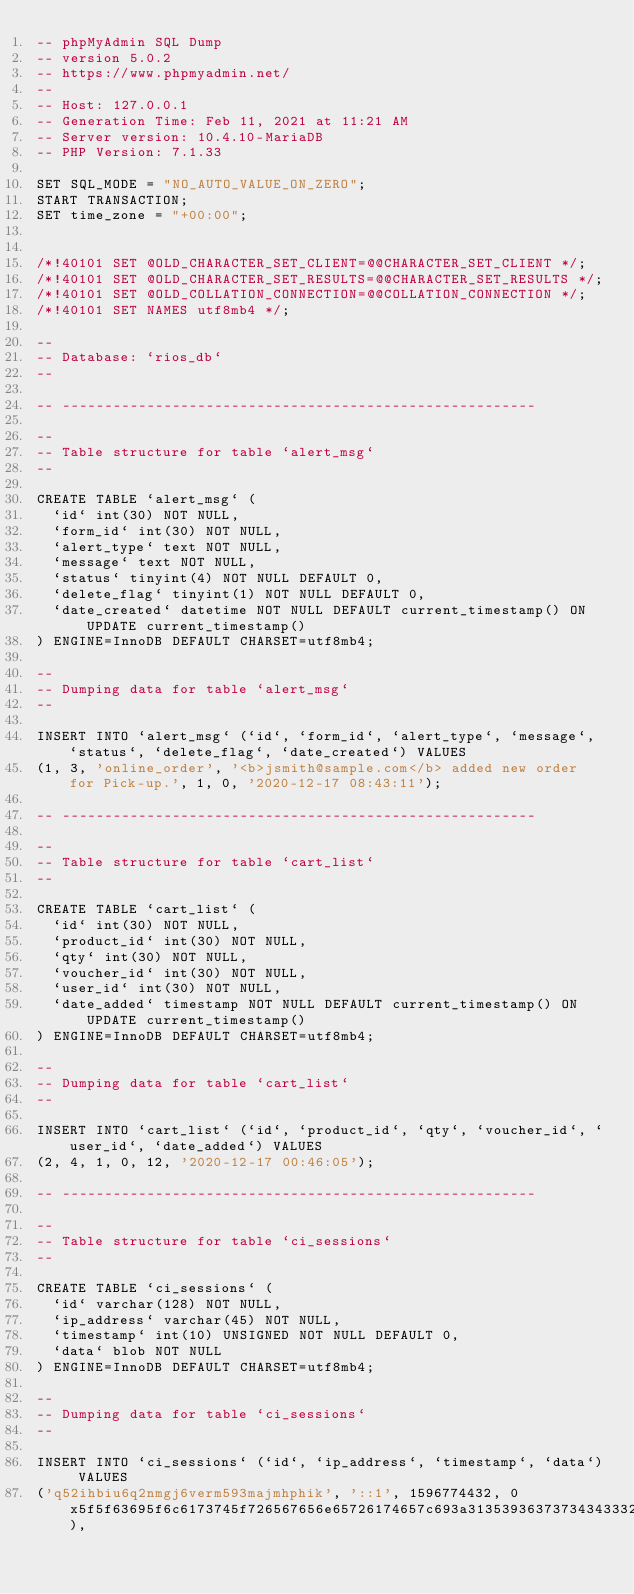<code> <loc_0><loc_0><loc_500><loc_500><_SQL_>-- phpMyAdmin SQL Dump
-- version 5.0.2
-- https://www.phpmyadmin.net/
--
-- Host: 127.0.0.1
-- Generation Time: Feb 11, 2021 at 11:21 AM
-- Server version: 10.4.10-MariaDB
-- PHP Version: 7.1.33

SET SQL_MODE = "NO_AUTO_VALUE_ON_ZERO";
START TRANSACTION;
SET time_zone = "+00:00";


/*!40101 SET @OLD_CHARACTER_SET_CLIENT=@@CHARACTER_SET_CLIENT */;
/*!40101 SET @OLD_CHARACTER_SET_RESULTS=@@CHARACTER_SET_RESULTS */;
/*!40101 SET @OLD_COLLATION_CONNECTION=@@COLLATION_CONNECTION */;
/*!40101 SET NAMES utf8mb4 */;

--
-- Database: `rios_db`
--

-- --------------------------------------------------------

--
-- Table structure for table `alert_msg`
--

CREATE TABLE `alert_msg` (
  `id` int(30) NOT NULL,
  `form_id` int(30) NOT NULL,
  `alert_type` text NOT NULL,
  `message` text NOT NULL,
  `status` tinyint(4) NOT NULL DEFAULT 0,
  `delete_flag` tinyint(1) NOT NULL DEFAULT 0,
  `date_created` datetime NOT NULL DEFAULT current_timestamp() ON UPDATE current_timestamp()
) ENGINE=InnoDB DEFAULT CHARSET=utf8mb4;

--
-- Dumping data for table `alert_msg`
--

INSERT INTO `alert_msg` (`id`, `form_id`, `alert_type`, `message`, `status`, `delete_flag`, `date_created`) VALUES
(1, 3, 'online_order', '<b>jsmith@sample.com</b> added new order for Pick-up.', 1, 0, '2020-12-17 08:43:11');

-- --------------------------------------------------------

--
-- Table structure for table `cart_list`
--

CREATE TABLE `cart_list` (
  `id` int(30) NOT NULL,
  `product_id` int(30) NOT NULL,
  `qty` int(30) NOT NULL,
  `voucher_id` int(30) NOT NULL,
  `user_id` int(30) NOT NULL,
  `date_added` timestamp NOT NULL DEFAULT current_timestamp() ON UPDATE current_timestamp()
) ENGINE=InnoDB DEFAULT CHARSET=utf8mb4;

--
-- Dumping data for table `cart_list`
--

INSERT INTO `cart_list` (`id`, `product_id`, `qty`, `voucher_id`, `user_id`, `date_added`) VALUES
(2, 4, 1, 0, 12, '2020-12-17 00:46:05');

-- --------------------------------------------------------

--
-- Table structure for table `ci_sessions`
--

CREATE TABLE `ci_sessions` (
  `id` varchar(128) NOT NULL,
  `ip_address` varchar(45) NOT NULL,
  `timestamp` int(10) UNSIGNED NOT NULL DEFAULT 0,
  `data` blob NOT NULL
) ENGINE=InnoDB DEFAULT CHARSET=utf8mb4;

--
-- Dumping data for table `ci_sessions`
--

INSERT INTO `ci_sessions` (`id`, `ip_address`, `timestamp`, `data`) VALUES
('q52ihbiu6q2nmgj6verm593majmhphik', '::1', 1596774432, 0x5f5f63695f6c6173745f726567656e65726174657c693a313539363737343433323b757365725f69647c733a313a2238223b66697273746e616d657c733a353a2261646d696e223b6c6173746e616d657c733a353a2261646d696e223b6163636573735f746f6b656e7c733a303a22223b70686f6e655f6e756d6265727c733a303a22223b656d61696c7c733a353a2261646d696e223b747970657c733a313a2231223b7374617475737c733a313a2231223b64656c6574655f666c61677c733a313a2230223b646174655f637265617465647c733a31393a22323032302d30352d30362030303a30343a3137223b),</code> 